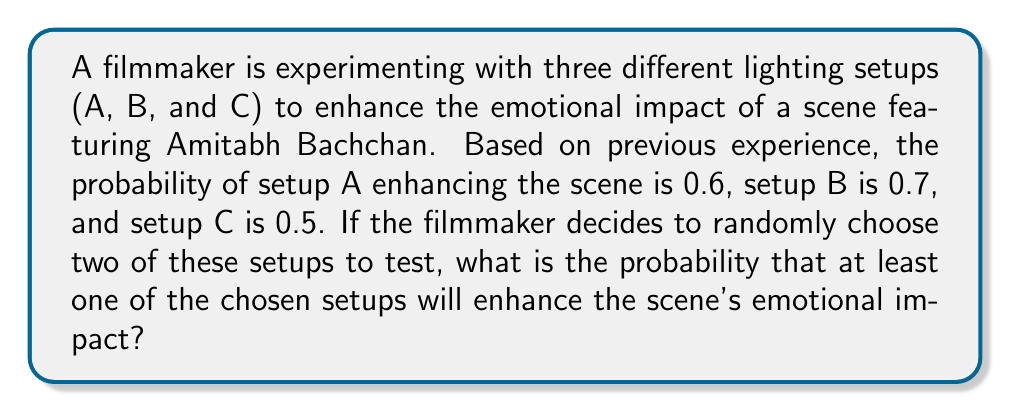Can you solve this math problem? Let's approach this step-by-step:

1) First, we need to calculate the probability of choosing any two setups out of the three. There are $\binom{3}{2} = 3$ possible combinations: (A,B), (A,C), and (B,C).

2) For each combination, we need to calculate the probability that at least one setup enhances the scene. This is easier to calculate by finding the probability that neither setup enhances the scene and subtracting it from 1.

3) For combination (A,B):
   P(at least one enhances) = 1 - P(neither enhances)
   $$ = 1 - (1-0.6)(1-0.7) = 1 - 0.4 \times 0.3 = 1 - 0.12 = 0.88 $$

4) For combination (A,C):
   $$ 1 - (1-0.6)(1-0.5) = 1 - 0.4 \times 0.5 = 1 - 0.2 = 0.8 $$

5) For combination (B,C):
   $$ 1 - (1-0.7)(1-0.5) = 1 - 0.3 \times 0.5 = 1 - 0.15 = 0.85 $$

6) The probability of each combination being chosen is equal (1/3). So, the overall probability is the average of these three probabilities:

   $$ P(\text{at least one enhances}) = \frac{0.88 + 0.8 + 0.85}{3} = \frac{2.53}{3} \approx 0.8433 $$
Answer: $\frac{2.53}{3} \approx 0.8433$ 